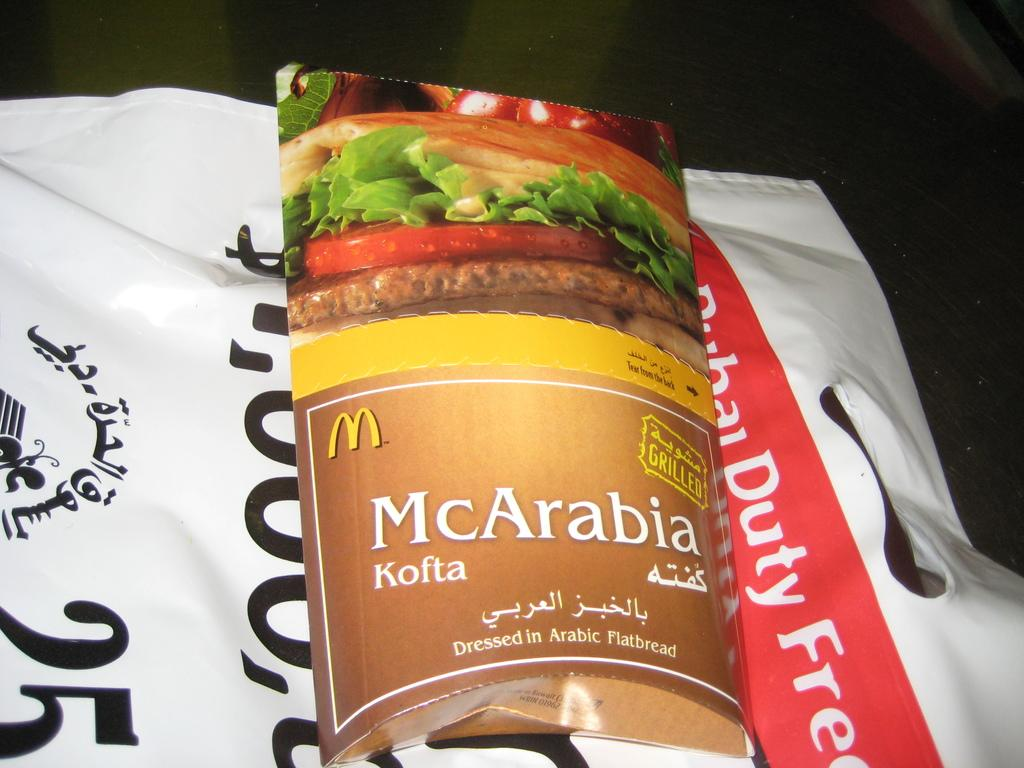What is the main subject of the image? The main subject of the image is a pack on a cover. Can you describe the background of the image? The background of the image is dark. How many cards are being played in the image? There are no cards visible in the image; it only features a pack on a cover with a dark background. What time of day is depicted in the image? The image does not provide any information about the time of day, as it only shows a pack on a cover with a dark background. 